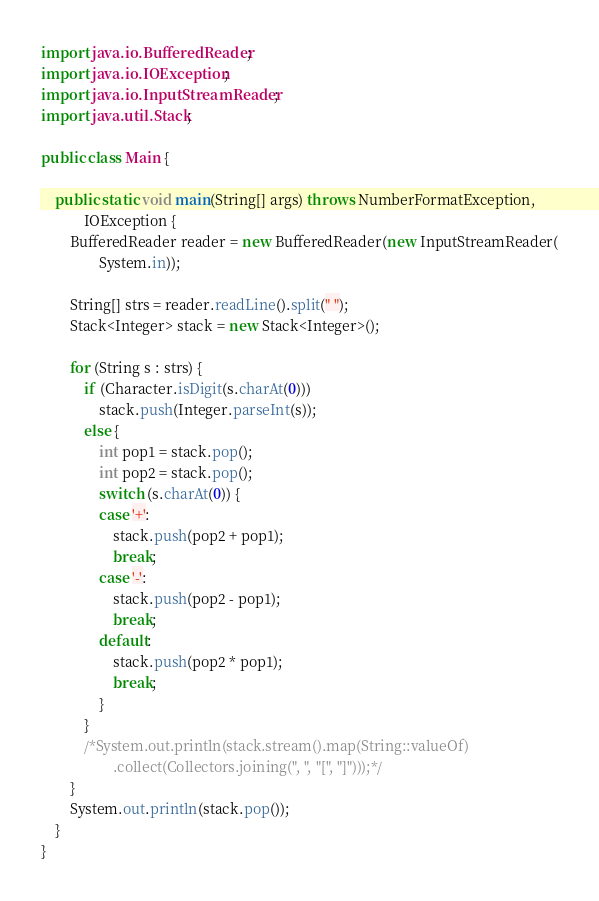<code> <loc_0><loc_0><loc_500><loc_500><_Java_>
import java.io.BufferedReader;
import java.io.IOException;
import java.io.InputStreamReader;
import java.util.Stack;

public class Main {

	public static void main(String[] args) throws NumberFormatException,
			IOException {
		BufferedReader reader = new BufferedReader(new InputStreamReader(
				System.in));

		String[] strs = reader.readLine().split(" ");
		Stack<Integer> stack = new Stack<Integer>();

		for (String s : strs) {
			if (Character.isDigit(s.charAt(0)))
				stack.push(Integer.parseInt(s));
			else {
				int pop1 = stack.pop();
				int pop2 = stack.pop();
				switch (s.charAt(0)) {
				case '+':
					stack.push(pop2 + pop1);
					break;
				case '-':
					stack.push(pop2 - pop1);
					break;
				default:
					stack.push(pop2 * pop1);
					break;
				}
			}
			/*System.out.println(stack.stream().map(String::valueOf)
					.collect(Collectors.joining(", ", "[", "]")));*/
		}
		System.out.println(stack.pop());
	}
}</code> 